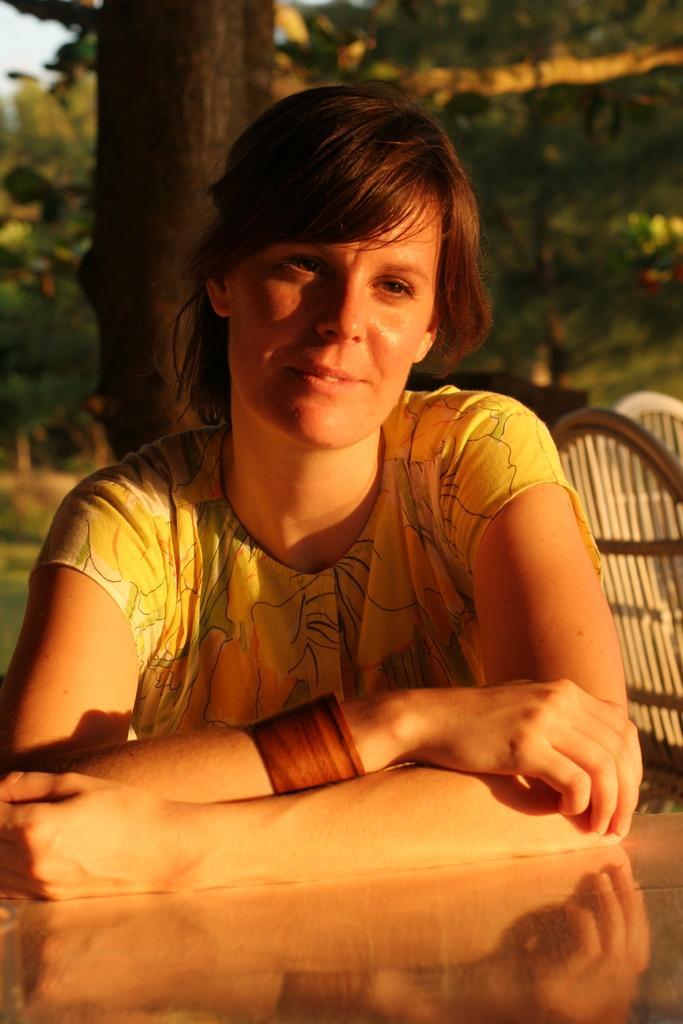How would you summarize this image in a sentence or two? In the background we can see the trees, branches and the chairs. In this picture we can see a woman. At the bottom portion of the picture we can see the reflection on the platform. 